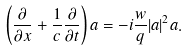Convert formula to latex. <formula><loc_0><loc_0><loc_500><loc_500>\left ( \frac { \partial } { \partial x } + \frac { 1 } { c } \frac { \partial } { \partial t } \right ) a = - i \frac { w } { q } | a | ^ { 2 } a .</formula> 